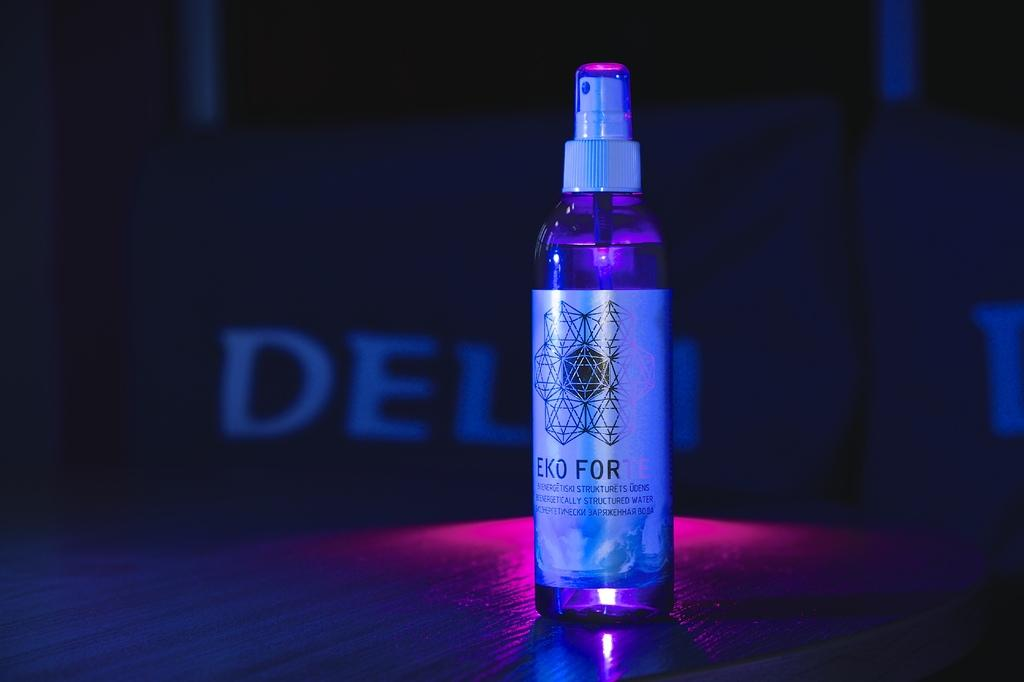<image>
Write a terse but informative summary of the picture. A container with a pump spray on top that says EKO FOR on the label. 